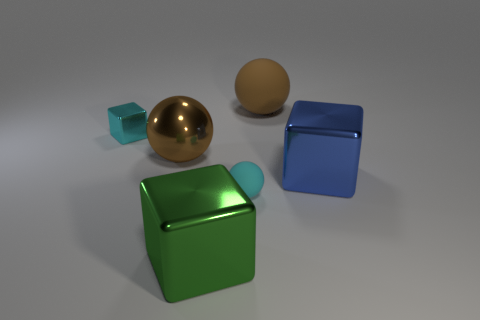Do the cyan thing that is behind the cyan matte ball and the thing that is on the right side of the large brown rubber sphere have the same shape?
Offer a very short reply. Yes. There is a metal object that is to the left of the large metal thing behind the blue block; what number of brown objects are in front of it?
Keep it short and to the point. 1. The tiny rubber object is what color?
Your answer should be compact. Cyan. What number of other objects are the same size as the green thing?
Your answer should be compact. 3. There is another big object that is the same shape as the brown rubber thing; what is its material?
Your response must be concise. Metal. There is a large ball on the right side of the cyan object in front of the tiny block that is left of the big green shiny cube; what is it made of?
Give a very brief answer. Rubber. The cyan cube that is the same material as the large green thing is what size?
Provide a succinct answer. Small. There is a big ball that is left of the big brown matte ball; is it the same color as the big thing behind the cyan cube?
Offer a very short reply. Yes. There is a rubber ball behind the large blue metallic block; what is its color?
Ensure brevity in your answer.  Brown. Do the shiny cube in front of the cyan matte object and the cyan matte sphere have the same size?
Provide a succinct answer. No. 